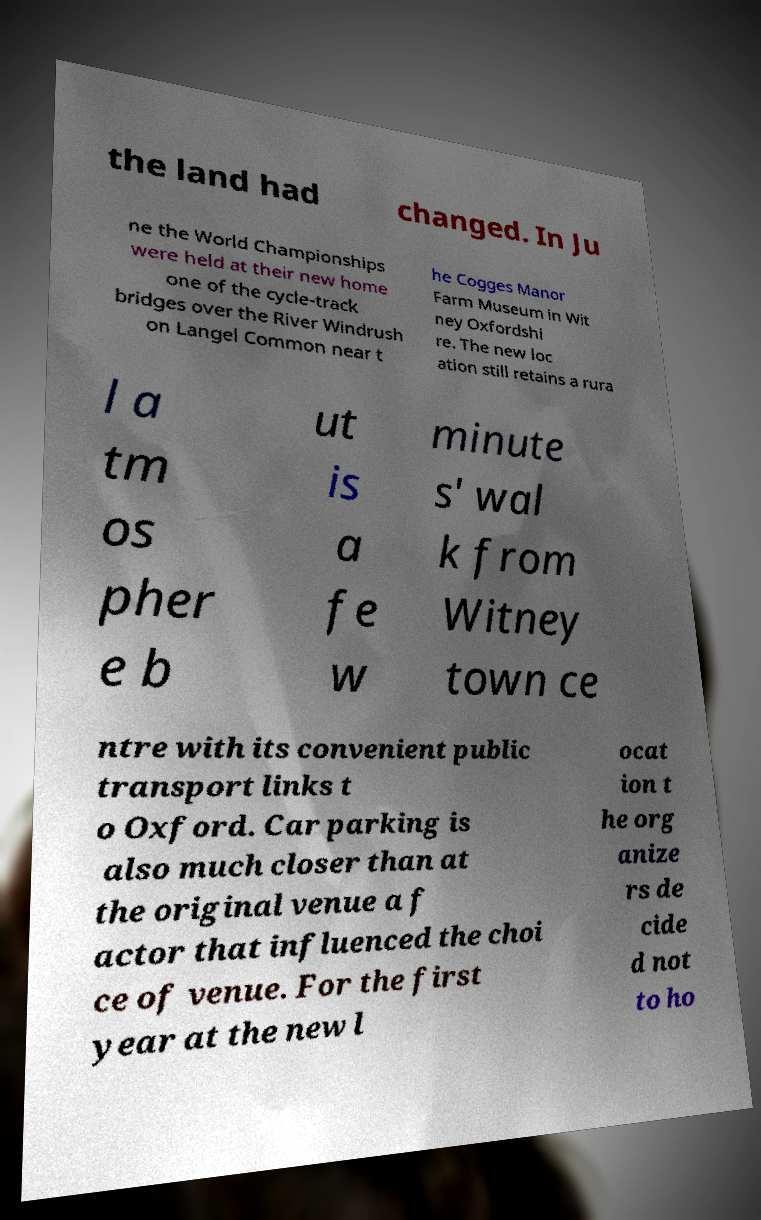Could you assist in decoding the text presented in this image and type it out clearly? the land had changed. In Ju ne the World Championships were held at their new home one of the cycle-track bridges over the River Windrush on Langel Common near t he Cogges Manor Farm Museum in Wit ney Oxfordshi re. The new loc ation still retains a rura l a tm os pher e b ut is a fe w minute s' wal k from Witney town ce ntre with its convenient public transport links t o Oxford. Car parking is also much closer than at the original venue a f actor that influenced the choi ce of venue. For the first year at the new l ocat ion t he org anize rs de cide d not to ho 